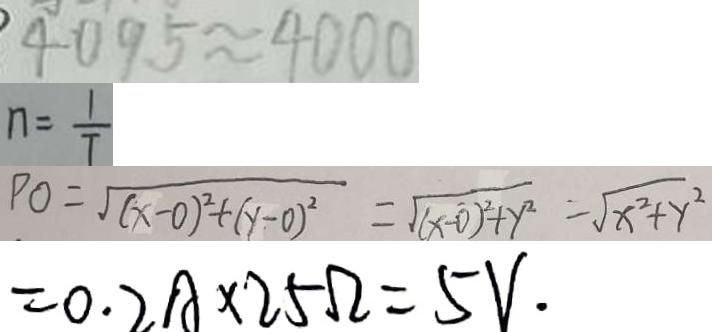Convert formula to latex. <formula><loc_0><loc_0><loc_500><loc_500>4 0 9 5 \approx 4 0 0 0 
 n = \frac { 1 } { T } 
 P O = \sqrt { ( x - 0 ) ^ { 2 } + ( y - 0 ) ^ { 2 } } = \sqrt { ( x - 0 ) ^ { 2 } + y ^ { 2 } } = \sqrt { x ^ { 2 } + y ^ { 2 } } 
 = 0 . 2 A \times 2 5 \Omega = 5 V .</formula> 